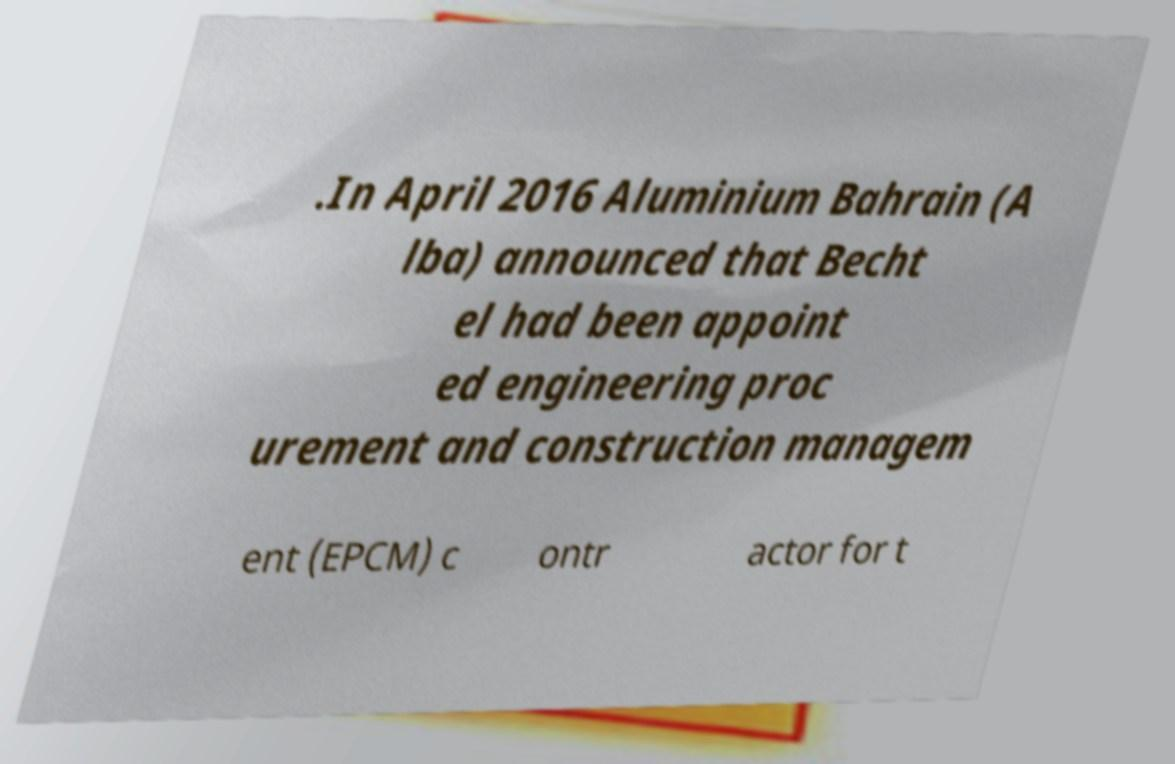For documentation purposes, I need the text within this image transcribed. Could you provide that? .In April 2016 Aluminium Bahrain (A lba) announced that Becht el had been appoint ed engineering proc urement and construction managem ent (EPCM) c ontr actor for t 